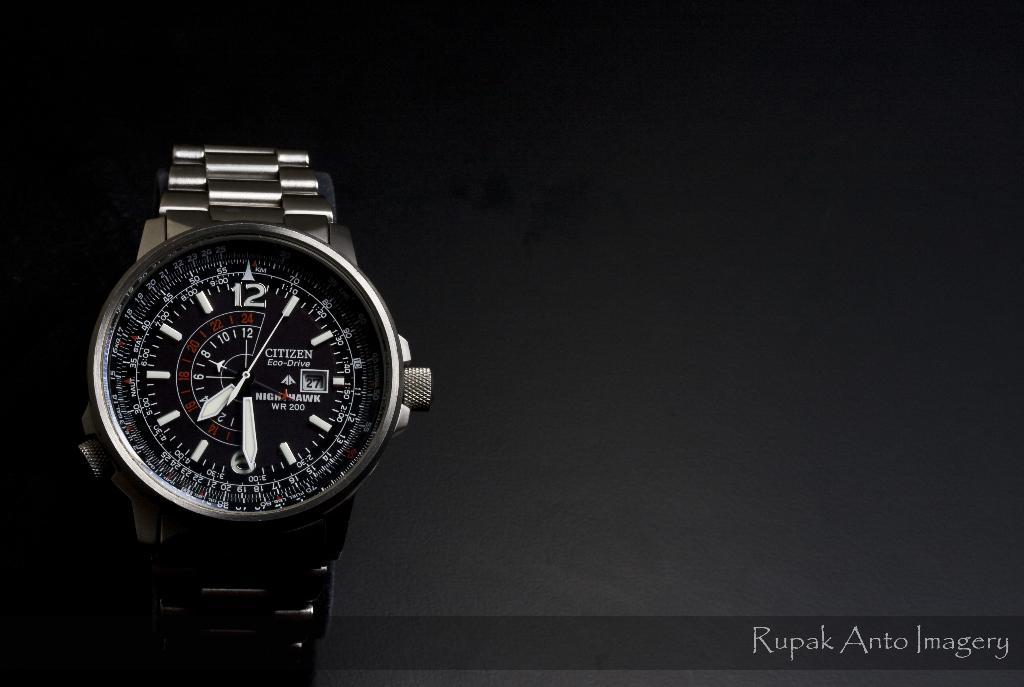<image>
Relay a brief, clear account of the picture shown. A black watch is on a dark background that says Rupak Anto Imagery. 